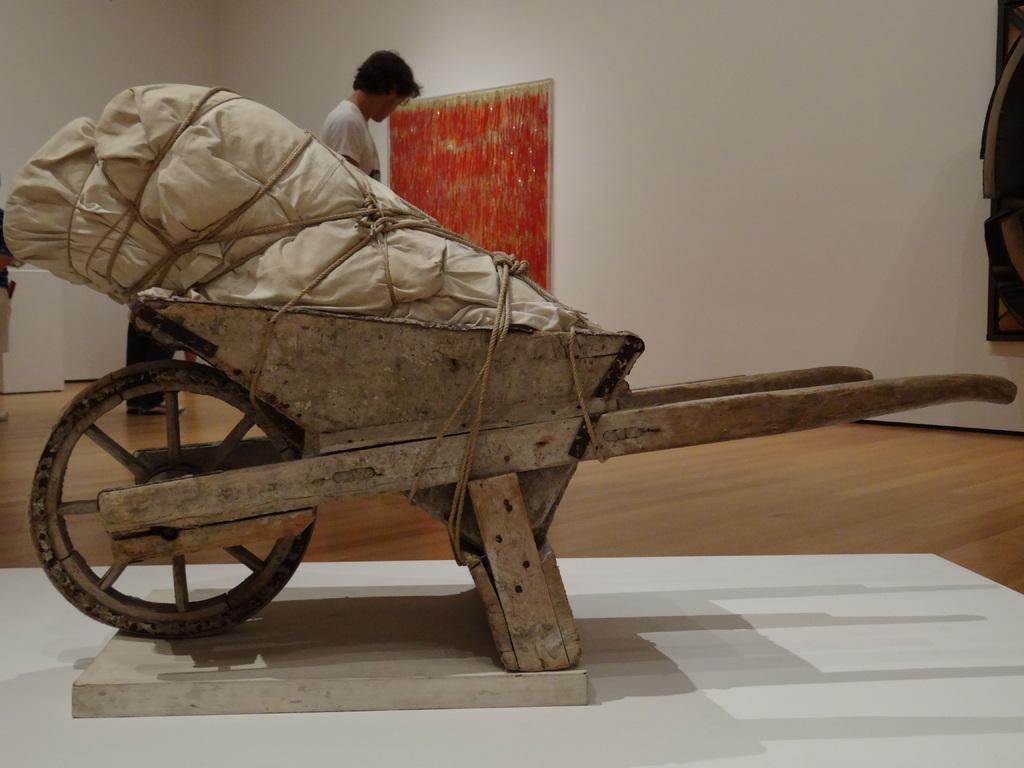Please provide a concise description of this image. In this image we can see a Wheelbarrow. We can see an object on the Wheelbarrow. There are few people in the image. There are few objects on the wall. 